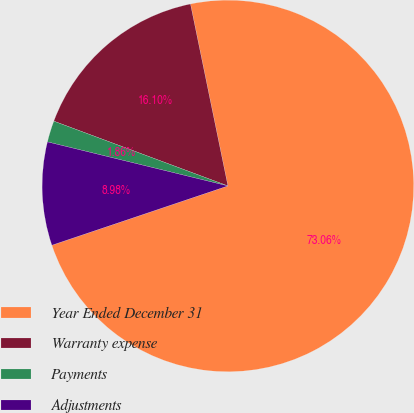Convert chart. <chart><loc_0><loc_0><loc_500><loc_500><pie_chart><fcel>Year Ended December 31<fcel>Warranty expense<fcel>Payments<fcel>Adjustments<nl><fcel>73.06%<fcel>16.1%<fcel>1.86%<fcel>8.98%<nl></chart> 